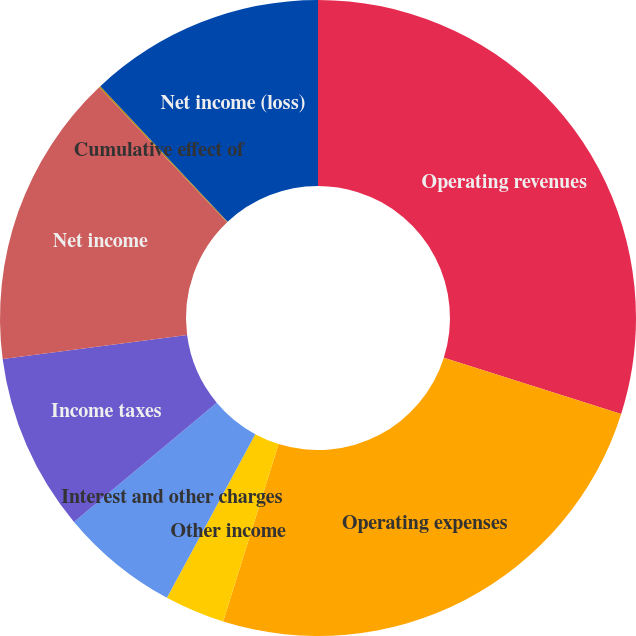Convert chart to OTSL. <chart><loc_0><loc_0><loc_500><loc_500><pie_chart><fcel>Operating revenues<fcel>Operating expenses<fcel>Other income<fcel>Interest and other charges<fcel>Income taxes<fcel>Net income<fcel>Cumulative effect of<fcel>Net income (loss)<nl><fcel>29.88%<fcel>24.94%<fcel>3.06%<fcel>6.04%<fcel>9.02%<fcel>14.98%<fcel>0.08%<fcel>12.0%<nl></chart> 